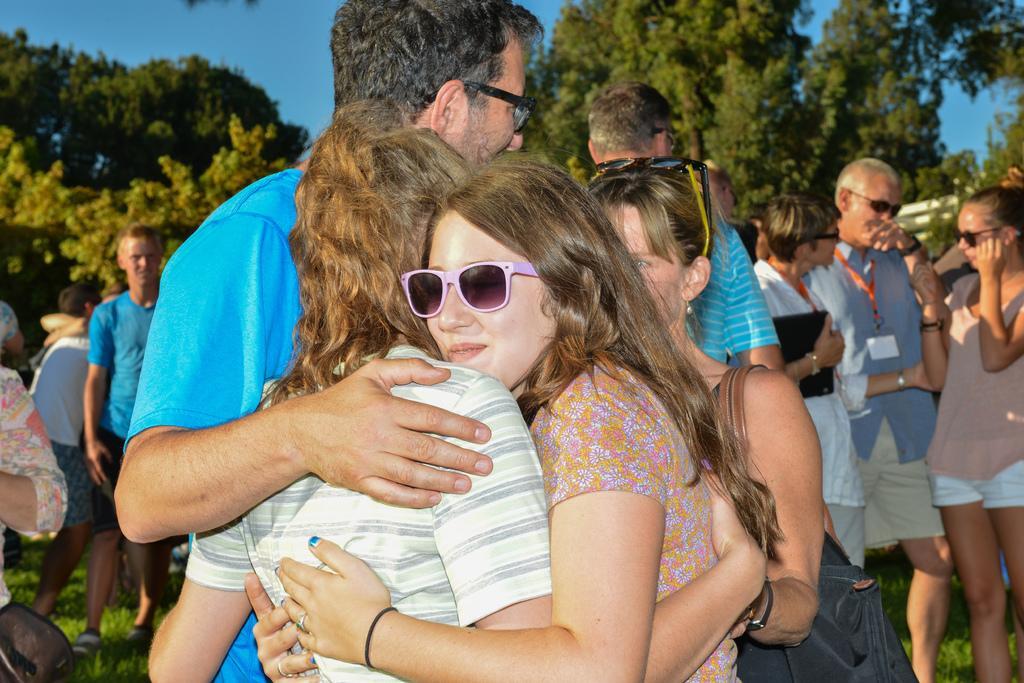Please provide a concise description of this image. In front of the picture, we see two women are hugging. Beside them, we see a man in blue T-shirt is standing. Behind them, there are many people standing. At the bottom of the picture, we see the grass. There are trees in the background. At the top of the picture, we see the sky. 